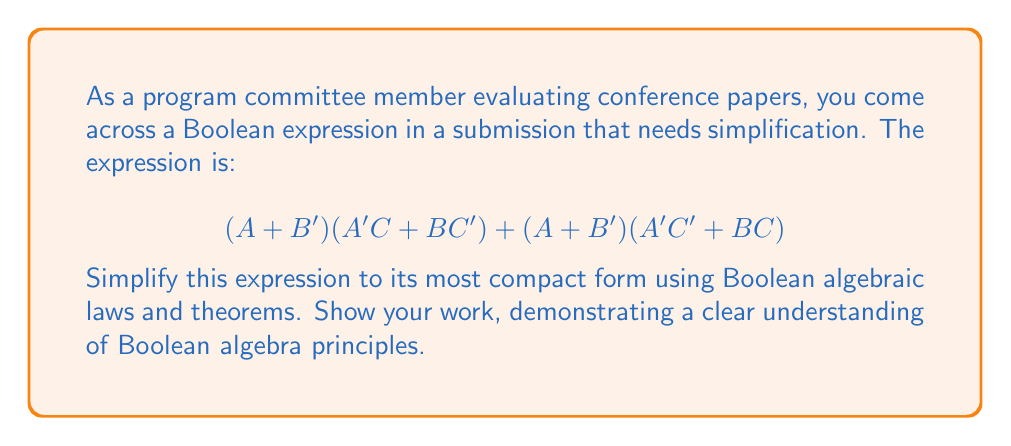Can you answer this question? Let's simplify this expression step by step:

1) First, let's distribute $(A + B')$ over both terms:
   $$(A + B')(A'C + BC') + (A + B')(A'C' + BC)$$
   $= AA'C + ABC' + B'A'C + B'BC' + AA'C' + ABC + B'A'C' + B'BC$$

2) Simplify using the following laws:
   - $AA' = 0$ (Complement law)
   - $B'B = 0$ (Complement law)
   
   This gives us:
   $= ABC' + B'A'C + ABC + B'A'C'$

3) Group terms with $A$ and terms with $A'$:
   $= A(BC' + BC) + A'(B'C + B'C')$

4) Simplify inside the parentheses:
   - $BC' + BC = B(C' + C) = B$ (Complement law)
   - $B'C + B'C' = B'(C + C') = B'$ (Complement law)

   This gives us:
   $= AB + A'B'$

5) This is the exclusive OR (XOR) operation, which can be written as:
   $= A \oplus B$

Thus, the simplified expression is $A \oplus B$.
Answer: $A \oplus B$ 